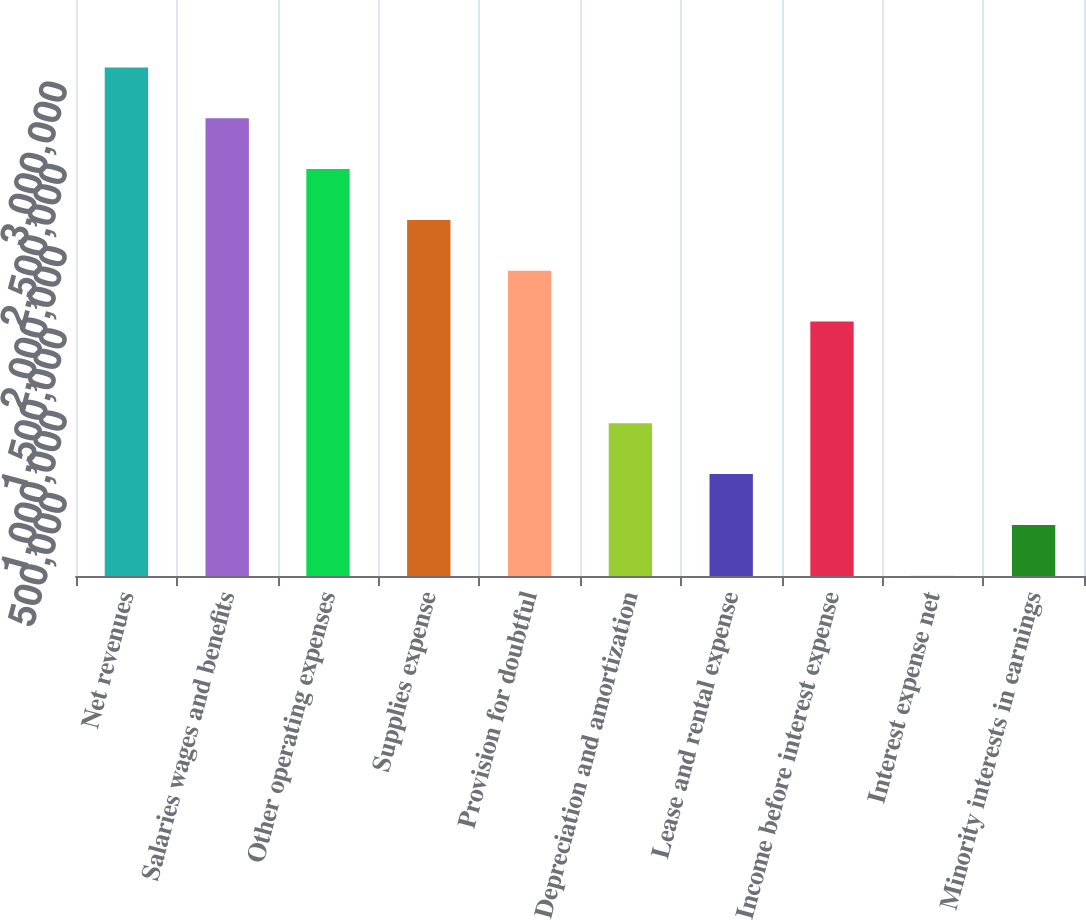<chart> <loc_0><loc_0><loc_500><loc_500><bar_chart><fcel>Net revenues<fcel>Salaries wages and benefits<fcel>Other operating expenses<fcel>Supplies expense<fcel>Provision for doubtful<fcel>Depreciation and amortization<fcel>Lease and rental expense<fcel>Income before interest expense<fcel>Interest expense net<fcel>Minority interests in earnings<nl><fcel>3.09052e+06<fcel>2.78163e+06<fcel>2.47274e+06<fcel>2.16385e+06<fcel>1.85496e+06<fcel>928291<fcel>619400<fcel>1.54607e+06<fcel>1619<fcel>310510<nl></chart> 